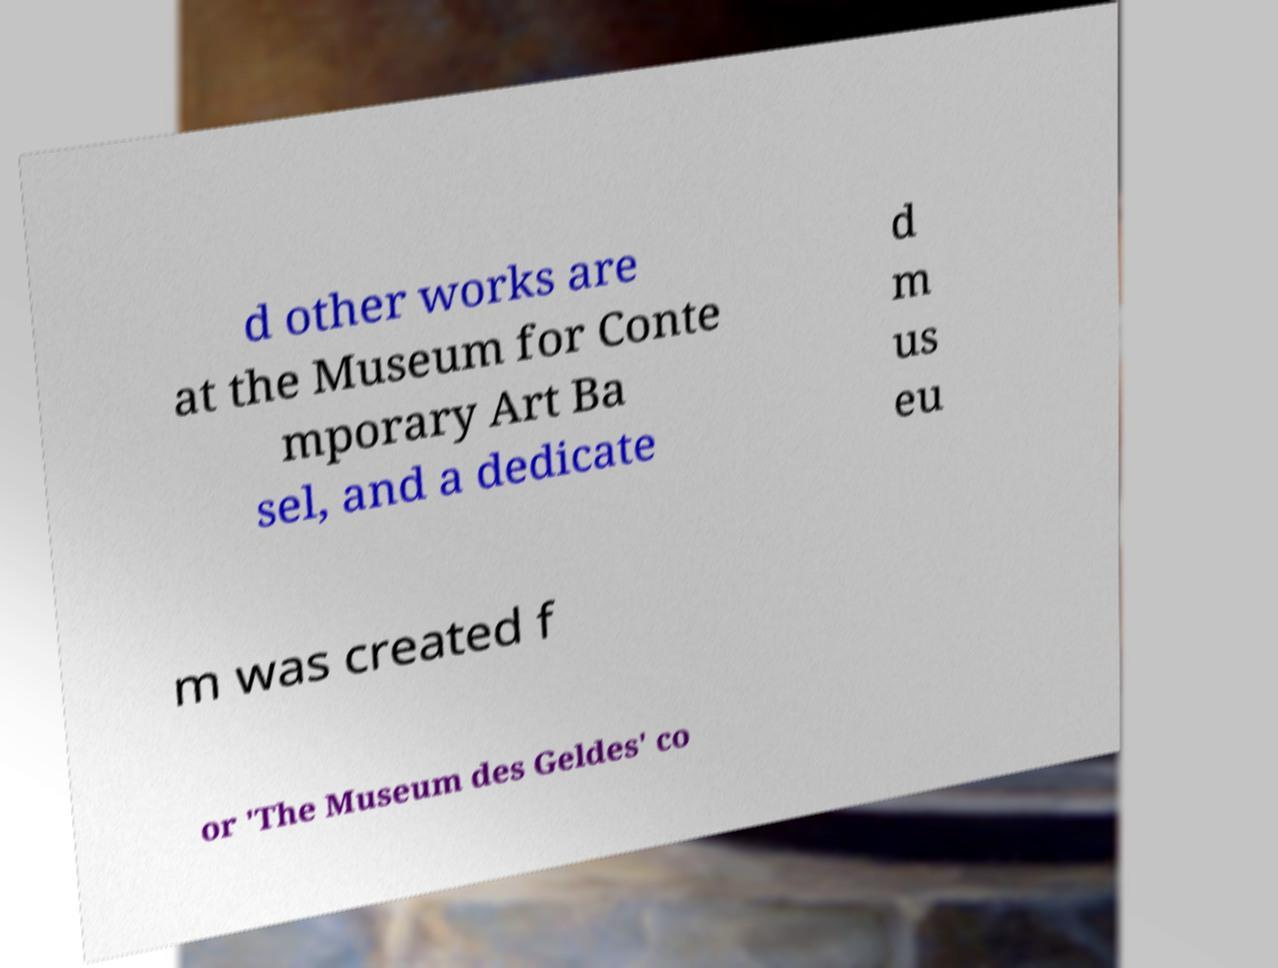Please identify and transcribe the text found in this image. d other works are at the Museum for Conte mporary Art Ba sel, and a dedicate d m us eu m was created f or 'The Museum des Geldes' co 